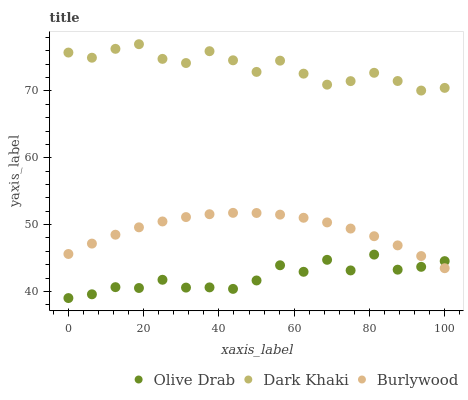Does Olive Drab have the minimum area under the curve?
Answer yes or no. Yes. Does Dark Khaki have the maximum area under the curve?
Answer yes or no. Yes. Does Burlywood have the minimum area under the curve?
Answer yes or no. No. Does Burlywood have the maximum area under the curve?
Answer yes or no. No. Is Burlywood the smoothest?
Answer yes or no. Yes. Is Olive Drab the roughest?
Answer yes or no. Yes. Is Olive Drab the smoothest?
Answer yes or no. No. Is Burlywood the roughest?
Answer yes or no. No. Does Olive Drab have the lowest value?
Answer yes or no. Yes. Does Burlywood have the lowest value?
Answer yes or no. No. Does Dark Khaki have the highest value?
Answer yes or no. Yes. Does Burlywood have the highest value?
Answer yes or no. No. Is Olive Drab less than Dark Khaki?
Answer yes or no. Yes. Is Dark Khaki greater than Olive Drab?
Answer yes or no. Yes. Does Burlywood intersect Olive Drab?
Answer yes or no. Yes. Is Burlywood less than Olive Drab?
Answer yes or no. No. Is Burlywood greater than Olive Drab?
Answer yes or no. No. Does Olive Drab intersect Dark Khaki?
Answer yes or no. No. 